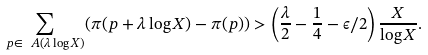<formula> <loc_0><loc_0><loc_500><loc_500>\sum _ { p \in \ A ( \lambda \log X ) } ( \pi ( p + \lambda \log X ) - \pi ( p ) ) > \left ( \frac { \lambda } { 2 } - \frac { 1 } { 4 } - \epsilon / 2 \right ) \frac { X } { \log X } .</formula> 